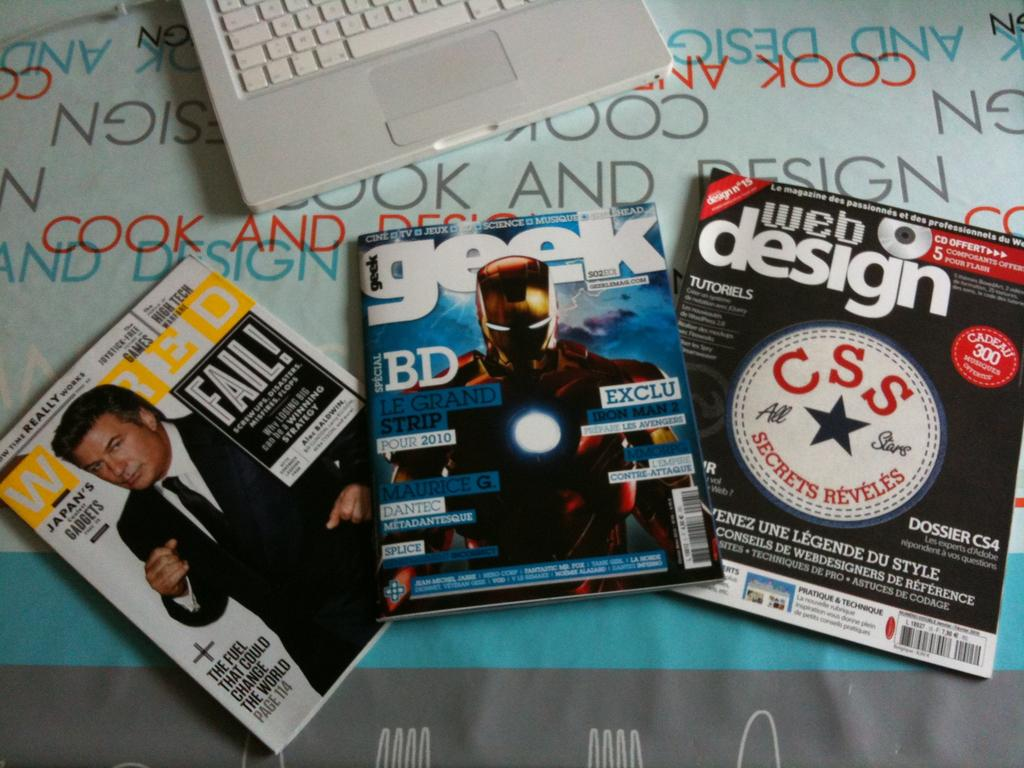<image>
Describe the image concisely. A number of computer magazines are spread out on a desk for Wired and Geek magazines. 